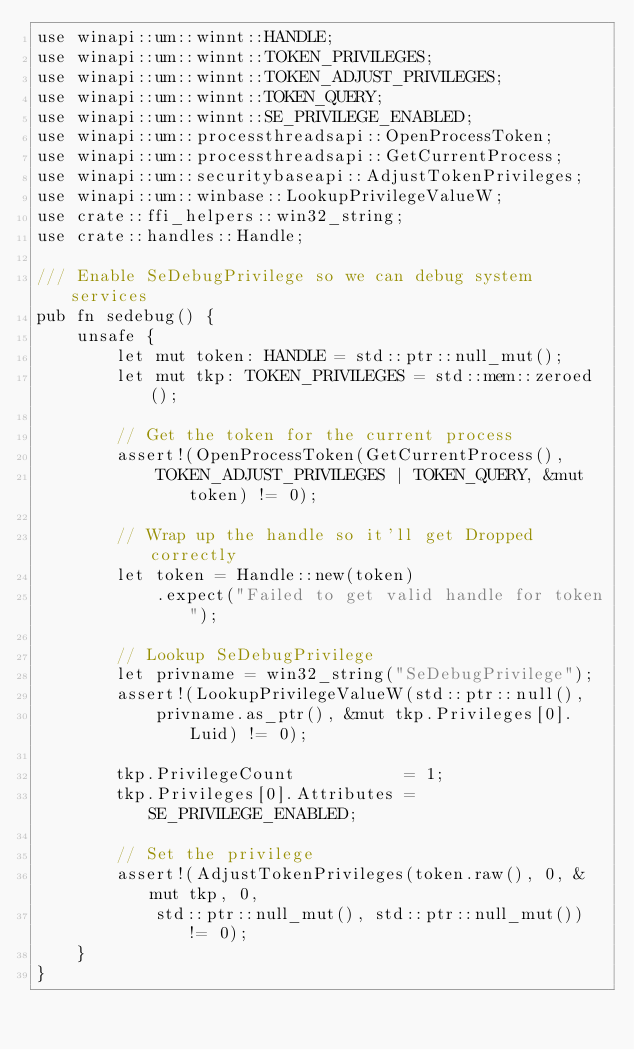<code> <loc_0><loc_0><loc_500><loc_500><_Rust_>use winapi::um::winnt::HANDLE;
use winapi::um::winnt::TOKEN_PRIVILEGES;
use winapi::um::winnt::TOKEN_ADJUST_PRIVILEGES;
use winapi::um::winnt::TOKEN_QUERY;
use winapi::um::winnt::SE_PRIVILEGE_ENABLED;
use winapi::um::processthreadsapi::OpenProcessToken;
use winapi::um::processthreadsapi::GetCurrentProcess;
use winapi::um::securitybaseapi::AdjustTokenPrivileges;
use winapi::um::winbase::LookupPrivilegeValueW;
use crate::ffi_helpers::win32_string;
use crate::handles::Handle;

/// Enable SeDebugPrivilege so we can debug system services
pub fn sedebug() {
    unsafe {
        let mut token: HANDLE = std::ptr::null_mut();
        let mut tkp: TOKEN_PRIVILEGES = std::mem::zeroed();

        // Get the token for the current process
        assert!(OpenProcessToken(GetCurrentProcess(), 
            TOKEN_ADJUST_PRIVILEGES | TOKEN_QUERY, &mut token) != 0);
        
        // Wrap up the handle so it'll get Dropped correctly
        let token = Handle::new(token)
            .expect("Failed to get valid handle for token");

        // Lookup SeDebugPrivilege
        let privname = win32_string("SeDebugPrivilege");
        assert!(LookupPrivilegeValueW(std::ptr::null(),
            privname.as_ptr(), &mut tkp.Privileges[0].Luid) != 0);

        tkp.PrivilegeCount           = 1;
        tkp.Privileges[0].Attributes = SE_PRIVILEGE_ENABLED;

        // Set the privilege
        assert!(AdjustTokenPrivileges(token.raw(), 0, &mut tkp, 0,
            std::ptr::null_mut(), std::ptr::null_mut()) != 0);
    }
}
</code> 